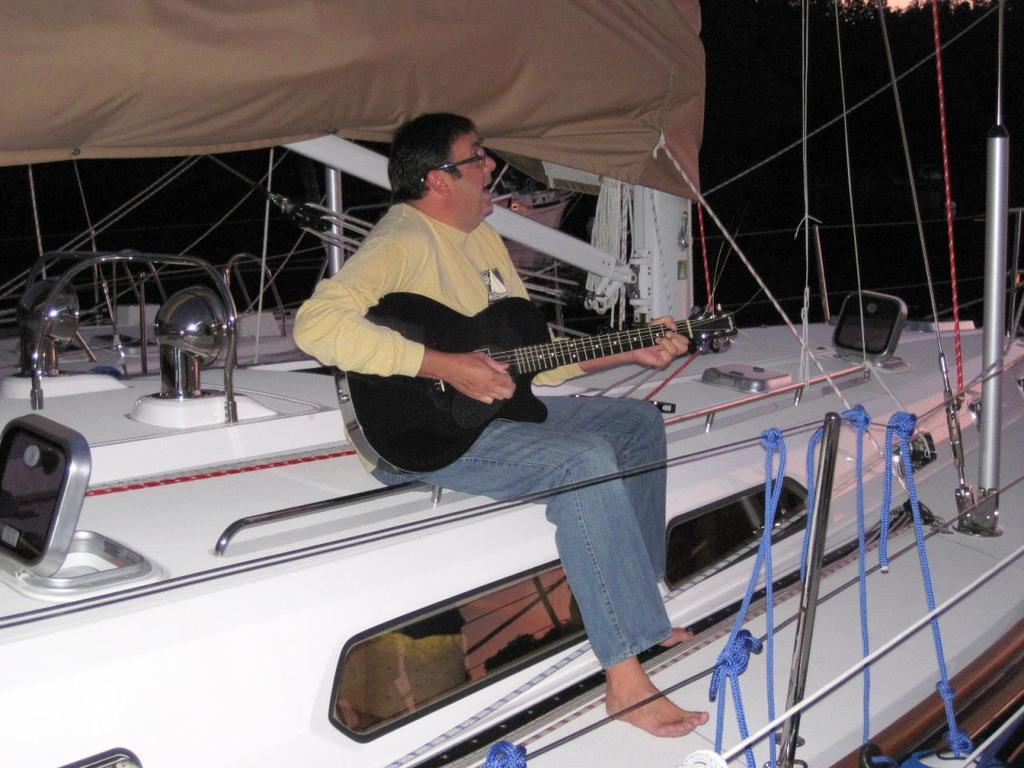Who is present in the image? There is a person in the image. What is the person doing in the image? The person is sitting on a boat and playing a guitar. How many sheep can be seen in the image? There are no sheep present in the image. What type of prose is the person reciting in the image? There is no indication in the image that the person is reciting any prose. 